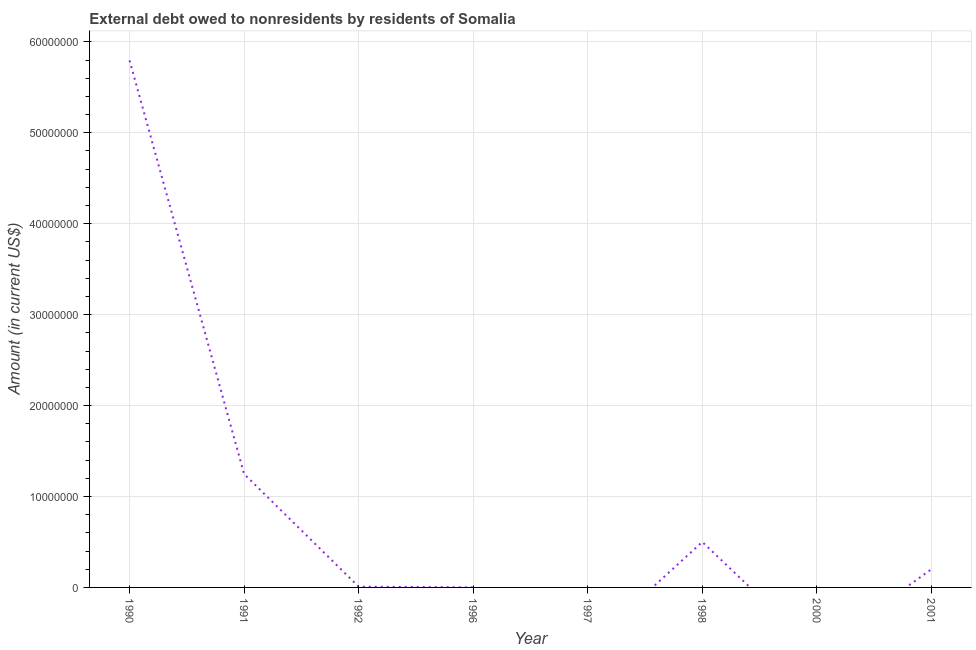What is the debt in 1991?
Provide a succinct answer. 1.25e+07. Across all years, what is the maximum debt?
Your response must be concise. 5.80e+07. What is the sum of the debt?
Your response must be concise. 7.75e+07. What is the difference between the debt in 1991 and 1992?
Give a very brief answer. 1.24e+07. What is the average debt per year?
Your response must be concise. 9.69e+06. What is the median debt?
Give a very brief answer. 1.04e+06. What is the ratio of the debt in 1992 to that in 1998?
Your answer should be compact. 0.02. Is the difference between the debt in 1992 and 1996 greater than the difference between any two years?
Provide a short and direct response. No. What is the difference between the highest and the second highest debt?
Offer a very short reply. 4.55e+07. What is the difference between the highest and the lowest debt?
Provide a short and direct response. 5.80e+07. In how many years, is the debt greater than the average debt taken over all years?
Your response must be concise. 2. Does the debt monotonically increase over the years?
Your answer should be compact. No. How many lines are there?
Provide a short and direct response. 1. Are the values on the major ticks of Y-axis written in scientific E-notation?
Ensure brevity in your answer.  No. Does the graph contain any zero values?
Your answer should be compact. Yes. Does the graph contain grids?
Keep it short and to the point. Yes. What is the title of the graph?
Provide a succinct answer. External debt owed to nonresidents by residents of Somalia. What is the label or title of the Y-axis?
Ensure brevity in your answer.  Amount (in current US$). What is the Amount (in current US$) in 1990?
Offer a very short reply. 5.80e+07. What is the Amount (in current US$) of 1991?
Your answer should be compact. 1.25e+07. What is the Amount (in current US$) of 1992?
Your answer should be compact. 8.10e+04. What is the Amount (in current US$) of 1996?
Your response must be concise. 1000. What is the Amount (in current US$) in 1998?
Give a very brief answer. 5.00e+06. What is the difference between the Amount (in current US$) in 1990 and 1991?
Ensure brevity in your answer.  4.55e+07. What is the difference between the Amount (in current US$) in 1990 and 1992?
Your answer should be compact. 5.79e+07. What is the difference between the Amount (in current US$) in 1990 and 1996?
Offer a very short reply. 5.80e+07. What is the difference between the Amount (in current US$) in 1990 and 1998?
Your response must be concise. 5.30e+07. What is the difference between the Amount (in current US$) in 1990 and 2001?
Offer a terse response. 5.60e+07. What is the difference between the Amount (in current US$) in 1991 and 1992?
Provide a short and direct response. 1.24e+07. What is the difference between the Amount (in current US$) in 1991 and 1996?
Give a very brief answer. 1.25e+07. What is the difference between the Amount (in current US$) in 1991 and 1998?
Offer a terse response. 7.48e+06. What is the difference between the Amount (in current US$) in 1991 and 2001?
Your answer should be very brief. 1.05e+07. What is the difference between the Amount (in current US$) in 1992 and 1998?
Offer a very short reply. -4.92e+06. What is the difference between the Amount (in current US$) in 1992 and 2001?
Your answer should be very brief. -1.92e+06. What is the difference between the Amount (in current US$) in 1996 and 1998?
Offer a terse response. -5.00e+06. What is the difference between the Amount (in current US$) in 1996 and 2001?
Offer a terse response. -2.00e+06. What is the difference between the Amount (in current US$) in 1998 and 2001?
Give a very brief answer. 3.00e+06. What is the ratio of the Amount (in current US$) in 1990 to that in 1991?
Your answer should be very brief. 4.65. What is the ratio of the Amount (in current US$) in 1990 to that in 1992?
Offer a terse response. 715.62. What is the ratio of the Amount (in current US$) in 1990 to that in 1996?
Your answer should be compact. 5.80e+04. What is the ratio of the Amount (in current US$) in 1990 to that in 1998?
Offer a terse response. 11.59. What is the ratio of the Amount (in current US$) in 1990 to that in 2001?
Your answer should be compact. 28.98. What is the ratio of the Amount (in current US$) in 1991 to that in 1992?
Offer a very short reply. 154.01. What is the ratio of the Amount (in current US$) in 1991 to that in 1996?
Give a very brief answer. 1.25e+04. What is the ratio of the Amount (in current US$) in 1991 to that in 1998?
Keep it short and to the point. 2.5. What is the ratio of the Amount (in current US$) in 1991 to that in 2001?
Provide a succinct answer. 6.24. What is the ratio of the Amount (in current US$) in 1992 to that in 1996?
Your answer should be compact. 81. What is the ratio of the Amount (in current US$) in 1992 to that in 1998?
Keep it short and to the point. 0.02. What is the ratio of the Amount (in current US$) in 1992 to that in 2001?
Your answer should be compact. 0.04. What is the ratio of the Amount (in current US$) in 1996 to that in 1998?
Offer a terse response. 0. What is the ratio of the Amount (in current US$) in 1996 to that in 2001?
Provide a succinct answer. 0. 